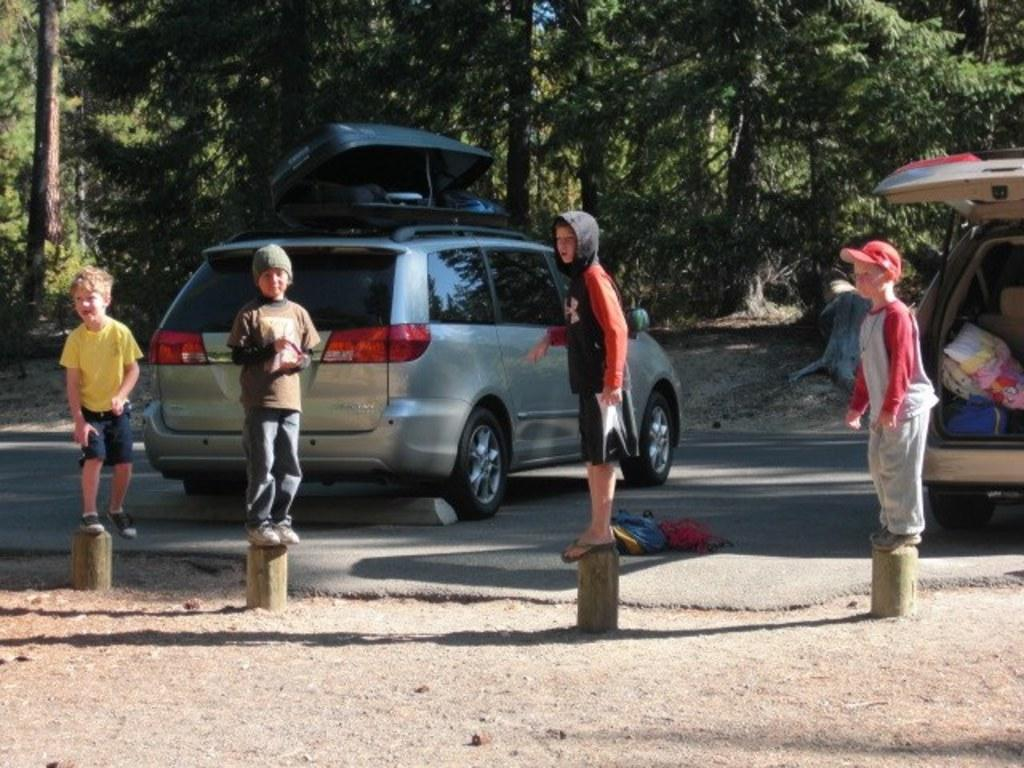What are the children doing in the image? The children are standing on an object in the image. What can be seen on the road in the image? There are two vehicles on the road in the image. Can you describe any other objects in the image besides the children and vehicles? There are some unspecified objects in the image. What is visible in the background of the image? There are trees in the background of the image. What type of harmony is being created by the children and the vehicles in the image? There is no harmony depicted between the children and the vehicles in the image, as they are separate subjects and no interaction is shown. 